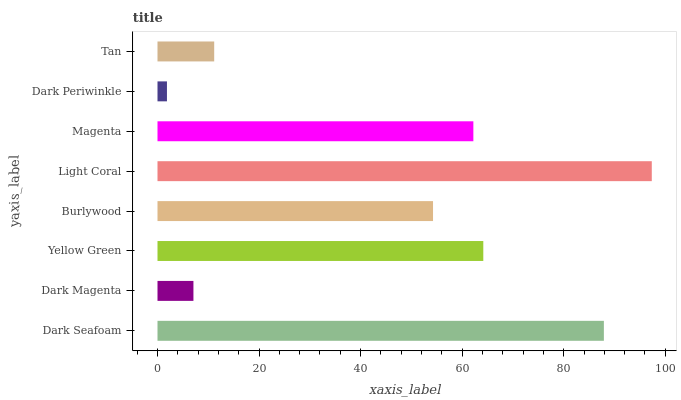Is Dark Periwinkle the minimum?
Answer yes or no. Yes. Is Light Coral the maximum?
Answer yes or no. Yes. Is Dark Magenta the minimum?
Answer yes or no. No. Is Dark Magenta the maximum?
Answer yes or no. No. Is Dark Seafoam greater than Dark Magenta?
Answer yes or no. Yes. Is Dark Magenta less than Dark Seafoam?
Answer yes or no. Yes. Is Dark Magenta greater than Dark Seafoam?
Answer yes or no. No. Is Dark Seafoam less than Dark Magenta?
Answer yes or no. No. Is Magenta the high median?
Answer yes or no. Yes. Is Burlywood the low median?
Answer yes or no. Yes. Is Burlywood the high median?
Answer yes or no. No. Is Dark Seafoam the low median?
Answer yes or no. No. 